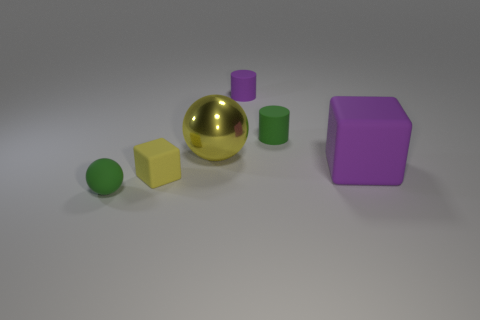There is a cylinder that is behind the green object behind the yellow thing behind the large purple rubber block; what is it made of?
Provide a succinct answer. Rubber. What number of small purple things are the same material as the small purple cylinder?
Offer a terse response. 0. What shape is the thing that is the same color as the big matte block?
Ensure brevity in your answer.  Cylinder. There is a matte thing that is the same size as the metal ball; what shape is it?
Your answer should be compact. Cube. There is a thing that is the same color as the big cube; what is its material?
Provide a short and direct response. Rubber. Are there any big matte blocks to the left of the yellow block?
Keep it short and to the point. No. Are there any small yellow things that have the same shape as the big metal thing?
Your answer should be very brief. No. Is the shape of the green matte object that is behind the tiny matte ball the same as the green rubber object that is in front of the shiny sphere?
Provide a short and direct response. No. Is there a metallic thing that has the same size as the purple matte cylinder?
Give a very brief answer. No. Are there the same number of green cylinders that are left of the tiny green ball and purple cylinders left of the large metal ball?
Provide a short and direct response. Yes. 